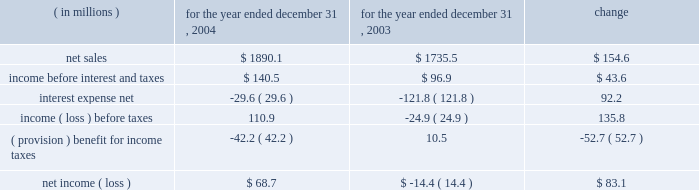Year ended december 31 , 2004 compared to year ended december 31 , 2003 the historical results of operations of pca for the years ended december 31 , 2004 and 2003 are set forth below : for the year ended december 31 , ( in millions ) 2004 2003 change .
Net sales net sales increased by $ 154.6 million , or 8.9% ( 8.9 % ) , for the year ended december 31 , 2004 from the year ended december 31 , 2003 .
Net sales increased due to improved sales volumes and prices of corrugated products and containerboard compared to 2003 .
Total corrugated products volume sold increased 6.6% ( 6.6 % ) to 29.9 billion square feet in 2004 compared to 28.1 billion square feet in 2003 .
On a comparable shipment-per-workday basis , corrugated products sales volume increased 7.0% ( 7.0 % ) in 2004 from 2003 .
Excluding pca 2019s acquisition of acorn in february 2004 , corrugated products volume was 5.3% ( 5.3 % ) higher in 2004 than 2003 and up 5.8% ( 5.8 % ) compared to 2003 on a shipment-per-workday basis .
Shipments-per-workday is calculated by dividing our total corrugated products volume during the year by the number of workdays within the year .
The larger percentage increase was due to the fact that 2004 had one less workday ( 251 days ) , those days not falling on a weekend or holiday , than 2003 ( 252 days ) .
Containerboard sales volume to external domestic and export customers increased 6.8% ( 6.8 % ) to 475000 tons for the year ended december 31 , 2004 from 445000 tons in 2003 .
Income before interest and taxes income before interest and taxes increased by $ 43.6 million , or 45.1% ( 45.1 % ) , for the year ended december 31 , 2004 compared to 2003 .
Included in income before interest and taxes for the year ended december 31 , 2004 is income of $ 27.8 million , net of expenses , attributable to a dividend paid to pca by stv , the timberlands joint venture in which pca owns a 311 20443% ( 20443 % ) ownership interest .
Included in income before interest and taxes for the year ended december 31 , 2003 is a $ 3.3 million charge for fees and expenses related to the company 2019s debt refinancing which was completed in july 2003 , and a fourth quarter charge of $ 16.0 million to settle certain benefits related matters with pactiv corporation dating back to april 12 , 1999 when pca became a stand-alone company , as described below .
During the fourth quarter of 2003 , pactiv notified pca that we owed pactiv additional amounts for hourly pension benefits and workers 2019 compensation liabilities dating back to april 12 , 1999 .
A settlement of $ 16.0 million was negotiated between pactiv and pca in december 2003 .
The full amount of the settlement was accrued in the fourth quarter of 2003 .
Excluding these special items , operating income decreased $ 3.4 million in 2004 compared to 2003 .
The $ 3.4 million decrease in income before interest and taxes was primarily attributable to increased energy and transportation costs ( $ 19.2 million ) , higher recycled and wood fiber costs ( $ 16.7 million ) , increased salary expenses related to annual increases and new hires ( $ 5.7 million ) , and increased contractual hourly labor costs ( $ 5.6 million ) , which was partially offset by increased sales volume and sales prices ( $ 44.3 million ) . .
What were operating expenses in 2003? 
Computations: (1735.5 - 96.9)
Answer: 1638.6. Year ended december 31 , 2004 compared to year ended december 31 , 2003 the historical results of operations of pca for the years ended december 31 , 2004 and 2003 are set forth below : for the year ended december 31 , ( in millions ) 2004 2003 change .
Net sales net sales increased by $ 154.6 million , or 8.9% ( 8.9 % ) , for the year ended december 31 , 2004 from the year ended december 31 , 2003 .
Net sales increased due to improved sales volumes and prices of corrugated products and containerboard compared to 2003 .
Total corrugated products volume sold increased 6.6% ( 6.6 % ) to 29.9 billion square feet in 2004 compared to 28.1 billion square feet in 2003 .
On a comparable shipment-per-workday basis , corrugated products sales volume increased 7.0% ( 7.0 % ) in 2004 from 2003 .
Excluding pca 2019s acquisition of acorn in february 2004 , corrugated products volume was 5.3% ( 5.3 % ) higher in 2004 than 2003 and up 5.8% ( 5.8 % ) compared to 2003 on a shipment-per-workday basis .
Shipments-per-workday is calculated by dividing our total corrugated products volume during the year by the number of workdays within the year .
The larger percentage increase was due to the fact that 2004 had one less workday ( 251 days ) , those days not falling on a weekend or holiday , than 2003 ( 252 days ) .
Containerboard sales volume to external domestic and export customers increased 6.8% ( 6.8 % ) to 475000 tons for the year ended december 31 , 2004 from 445000 tons in 2003 .
Income before interest and taxes income before interest and taxes increased by $ 43.6 million , or 45.1% ( 45.1 % ) , for the year ended december 31 , 2004 compared to 2003 .
Included in income before interest and taxes for the year ended december 31 , 2004 is income of $ 27.8 million , net of expenses , attributable to a dividend paid to pca by stv , the timberlands joint venture in which pca owns a 311 20443% ( 20443 % ) ownership interest .
Included in income before interest and taxes for the year ended december 31 , 2003 is a $ 3.3 million charge for fees and expenses related to the company 2019s debt refinancing which was completed in july 2003 , and a fourth quarter charge of $ 16.0 million to settle certain benefits related matters with pactiv corporation dating back to april 12 , 1999 when pca became a stand-alone company , as described below .
During the fourth quarter of 2003 , pactiv notified pca that we owed pactiv additional amounts for hourly pension benefits and workers 2019 compensation liabilities dating back to april 12 , 1999 .
A settlement of $ 16.0 million was negotiated between pactiv and pca in december 2003 .
The full amount of the settlement was accrued in the fourth quarter of 2003 .
Excluding these special items , operating income decreased $ 3.4 million in 2004 compared to 2003 .
The $ 3.4 million decrease in income before interest and taxes was primarily attributable to increased energy and transportation costs ( $ 19.2 million ) , higher recycled and wood fiber costs ( $ 16.7 million ) , increased salary expenses related to annual increases and new hires ( $ 5.7 million ) , and increased contractual hourly labor costs ( $ 5.6 million ) , which was partially offset by increased sales volume and sales prices ( $ 44.3 million ) . .
What were operating expenses in 2004? 
Computations: (1890.1 - 140.5)
Answer: 1749.6. 